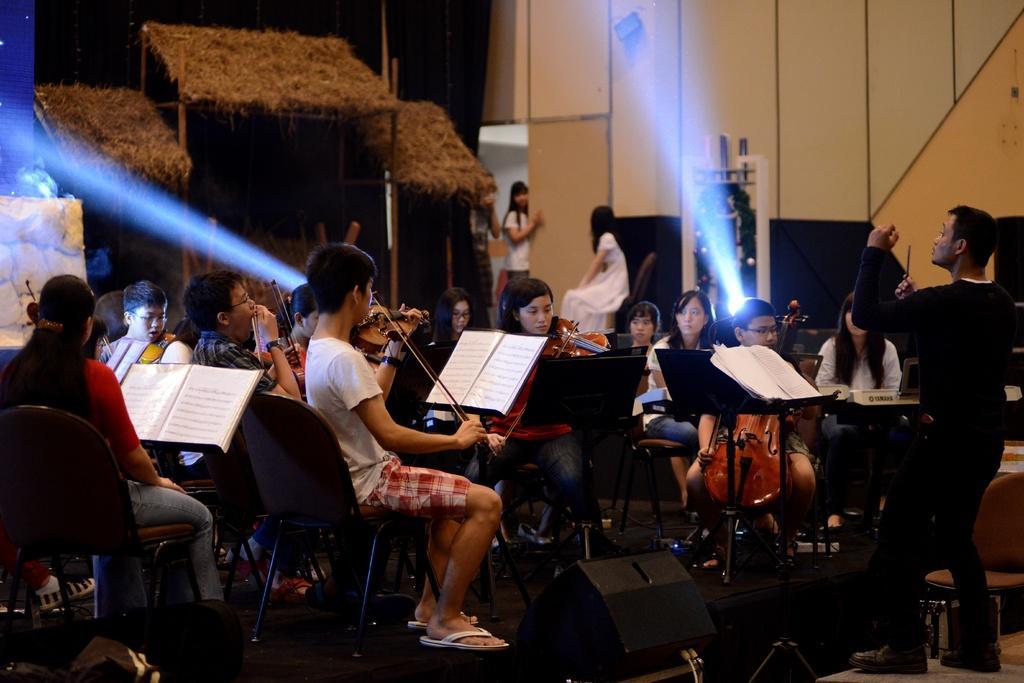How would you summarize this image in a sentence or two? In this picture I can see many women were playing a guitar and they are sitting on the chair. In front of them I can see the stand on which we can see some papers. In the background there is a woman who is standing near to the door. On the stage I can see the speakers and focus light. 